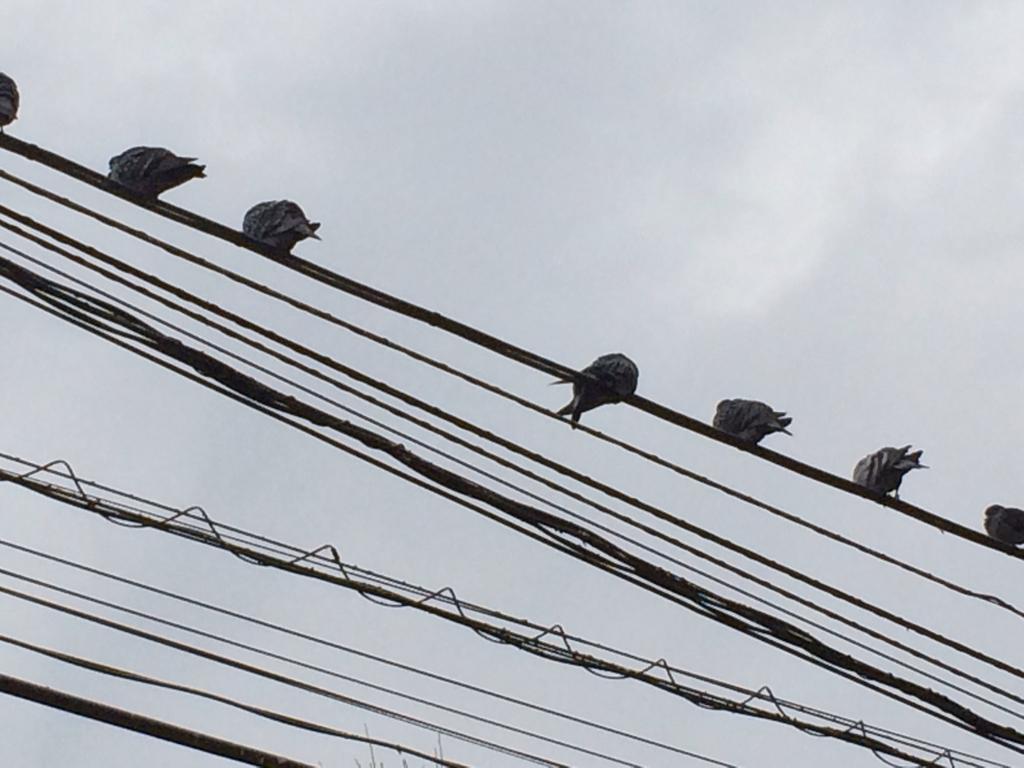How would you summarize this image in a sentence or two? In this image I can see number of wires in the front and on one wire I can see few birds. In the background I can see clouds and the sky. 